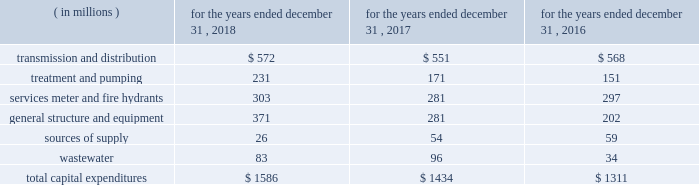The table provides a summary of our historical capital expenditures related to the upgrading of our infrastructure and systems: .
In 2018 , our capital expenditures increased $ 152 million , or 10.6% ( 10.6 % ) , primarily due to investment across the majority of our infrastructure categories .
In 2017 , our capital expenditures increased $ 123 million , or 9.4% ( 9.4 % ) , primarily due to investment in our general structure and equipment and wastewater categories .
We also grow our business primarily through acquisitions of water and wastewater systems , as well as other water-related services .
These acquisitions are complementary to our existing business and support continued geographical diversification and growth of our operations .
Generally , acquisitions are funded initially with short- term debt , and later refinanced with the proceeds from long-term debt .
The following is a summary of the acquisitions and dispositions affecting our cash flows from investing activities : 2022 the majority of cash paid for acquisitions pertained to the $ 365 million purchase of pivotal within our homeowner services group .
2022 paid $ 33 million for 15 water and wastewater systems , representing approximately 14000 customers .
2022 received $ 35 million for the sale of assets , including $ 27 million for the sale of the majority of the o&m contracts in our contract services group during the third quarter of 2018 .
2022 the majority of cash paid for acquisitions pertained to the $ 159 million purchase of the wastewater collection and treatment system assets of the municipal authority of the city of mckeesport , pennsylvania ( the 201cmckeesport system 201d ) , excluding a $ 5 million non-escrowed deposit made in 2016 .
2022 paid $ 18 million for 16 water and wastewater systems , excluding the mckeesport system and shorelands ( a stock-for-stock transaction ) , representing approximately 7000 customers .
2022 received $ 15 million for the sale of assets .
2022 paid $ 199 million for 15 water and wastewater systems , representing approximately 42000 customers .
2022 made a non-escrowed deposit of $ 5 million related to the mckeesport system acquisition .
2022 received $ 9 million for the sale of assets .
As previously noted , we expect to invest between $ 8.0 billion to $ 8.6 billion from 2019 to 2023 , with $ 7.3 billion of this range for infrastructure improvements in our regulated businesses .
In 2019 , we expect to .
What percentage of total capital expenditures were related to transmission and distribution in 2018? 
Computations: (572 / 1586)
Answer: 0.36066. 